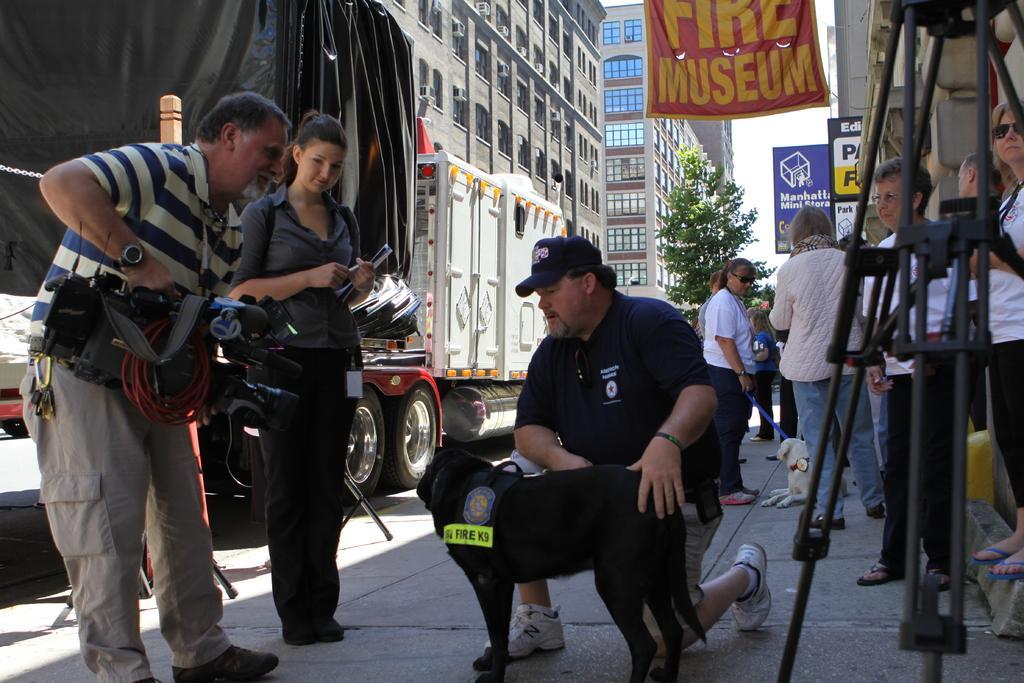Could you give a brief overview of what you see in this image? This image is clicked outside. There are buildings on the top. There is a tree in the middle. There is a truck on the left side. There are people standing on the right side. In the middle there is a man and a dog, beside them there are two people, in that one of them is holding video camera, other one is holding a book. 